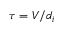<formula> <loc_0><loc_0><loc_500><loc_500>\tau = V / d _ { i }</formula> 